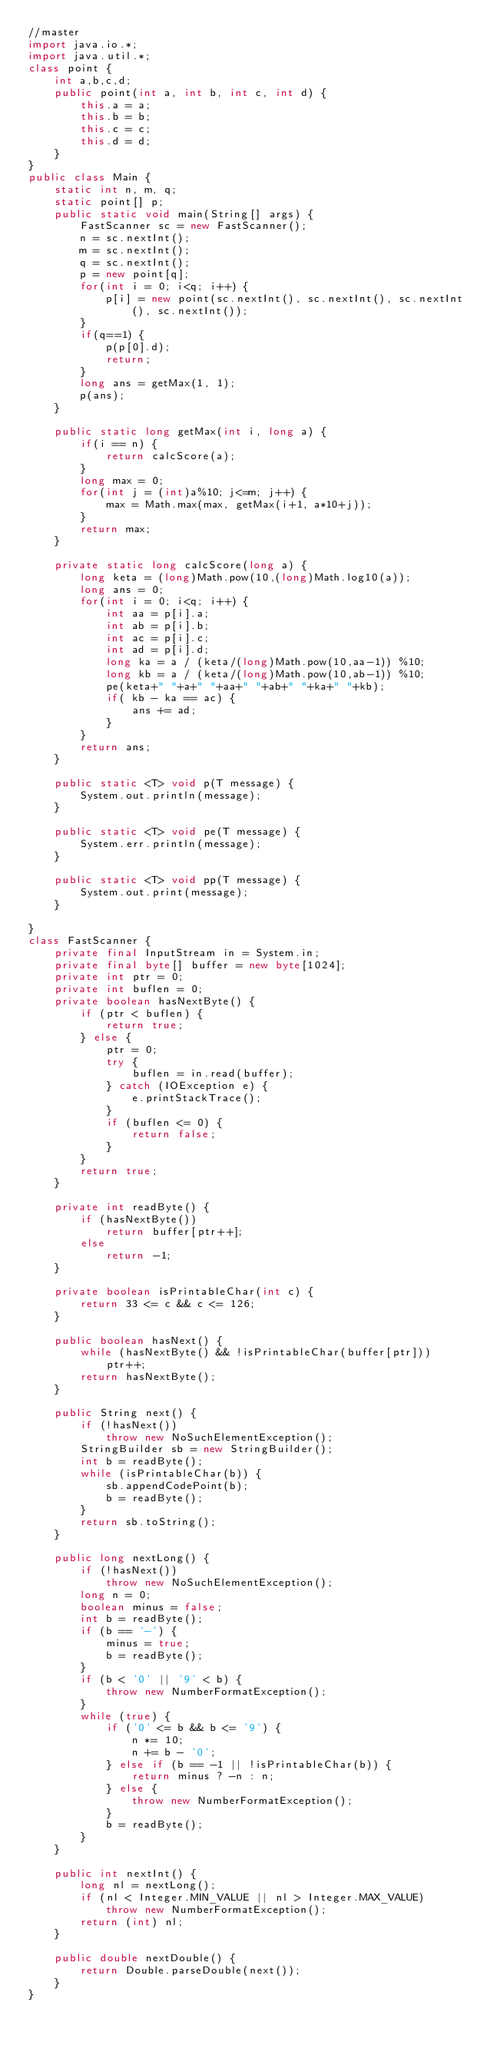<code> <loc_0><loc_0><loc_500><loc_500><_Java_>//master
import java.io.*;
import java.util.*;
class point {
    int a,b,c,d;
    public point(int a, int b, int c, int d) {
        this.a = a;
        this.b = b;
        this.c = c;
        this.d = d;
    }
}
public class Main {
    static int n, m, q;
    static point[] p;
    public static void main(String[] args) {
        FastScanner sc = new FastScanner();
        n = sc.nextInt();
        m = sc.nextInt();
        q = sc.nextInt();
        p = new point[q];
        for(int i = 0; i<q; i++) { 
            p[i] = new point(sc.nextInt(), sc.nextInt(), sc.nextInt(), sc.nextInt()); 
        }
        if(q==1) {
            p(p[0].d);
            return;
        }
        long ans = getMax(1, 1);
        p(ans);
    }

    public static long getMax(int i, long a) {
        if(i == n) {
            return calcScore(a);
        }
        long max = 0;
        for(int j = (int)a%10; j<=m; j++) {
            max = Math.max(max, getMax(i+1, a*10+j));
        }
        return max;
    }

    private static long calcScore(long a) {
        long keta = (long)Math.pow(10,(long)Math.log10(a));
        long ans = 0;
        for(int i = 0; i<q; i++) {
            int aa = p[i].a;
            int ab = p[i].b;
            int ac = p[i].c;
            int ad = p[i].d;
            long ka = a / (keta/(long)Math.pow(10,aa-1)) %10;
            long kb = a / (keta/(long)Math.pow(10,ab-1)) %10;
            pe(keta+" "+a+" "+aa+" "+ab+" "+ka+" "+kb);
            if( kb - ka == ac) {
                ans += ad;
            }
        }
        return ans;
    }

    public static <T> void p(T message) {
        System.out.println(message);
    }

    public static <T> void pe(T message) {
        System.err.println(message);
    }

    public static <T> void pp(T message) {
        System.out.print(message);
    }
    
}
class FastScanner {
    private final InputStream in = System.in;
    private final byte[] buffer = new byte[1024];
    private int ptr = 0;
    private int buflen = 0;
    private boolean hasNextByte() {
        if (ptr < buflen) {
            return true;
        } else {
            ptr = 0;
            try {
                buflen = in.read(buffer);
            } catch (IOException e) {
                e.printStackTrace();
            }
            if (buflen <= 0) {
                return false;
            }
        }
        return true;
    }
 
    private int readByte() {
        if (hasNextByte())
            return buffer[ptr++];
        else
            return -1;
    }
 
    private boolean isPrintableChar(int c) {
        return 33 <= c && c <= 126;
    }
 
    public boolean hasNext() {
        while (hasNextByte() && !isPrintableChar(buffer[ptr]))
            ptr++;
        return hasNextByte();
    }
 
    public String next() {
        if (!hasNext())
            throw new NoSuchElementException();
        StringBuilder sb = new StringBuilder();
        int b = readByte();
        while (isPrintableChar(b)) {
            sb.appendCodePoint(b);
            b = readByte();
        }
        return sb.toString();
    }
 
    public long nextLong() {
        if (!hasNext())
            throw new NoSuchElementException();
        long n = 0;
        boolean minus = false;
        int b = readByte();
        if (b == '-') {
            minus = true;
            b = readByte();
        }
        if (b < '0' || '9' < b) {
            throw new NumberFormatException();
        }
        while (true) {
            if ('0' <= b && b <= '9') {
                n *= 10;
                n += b - '0';
            } else if (b == -1 || !isPrintableChar(b)) {
                return minus ? -n : n;
            } else {
                throw new NumberFormatException();
            }
            b = readByte();
        }
    }
 
    public int nextInt() {
        long nl = nextLong();
        if (nl < Integer.MIN_VALUE || nl > Integer.MAX_VALUE)
            throw new NumberFormatException();
        return (int) nl;
    }
 
    public double nextDouble() {
        return Double.parseDouble(next());
    }
}
</code> 